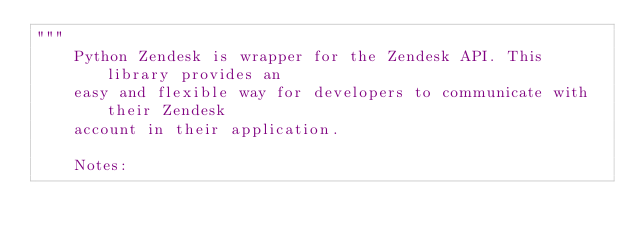Convert code to text. <code><loc_0><loc_0><loc_500><loc_500><_Python_>"""
    Python Zendesk is wrapper for the Zendesk API. This library provides an
    easy and flexible way for developers to communicate with their Zendesk
    account in their application.

    Notes:</code> 